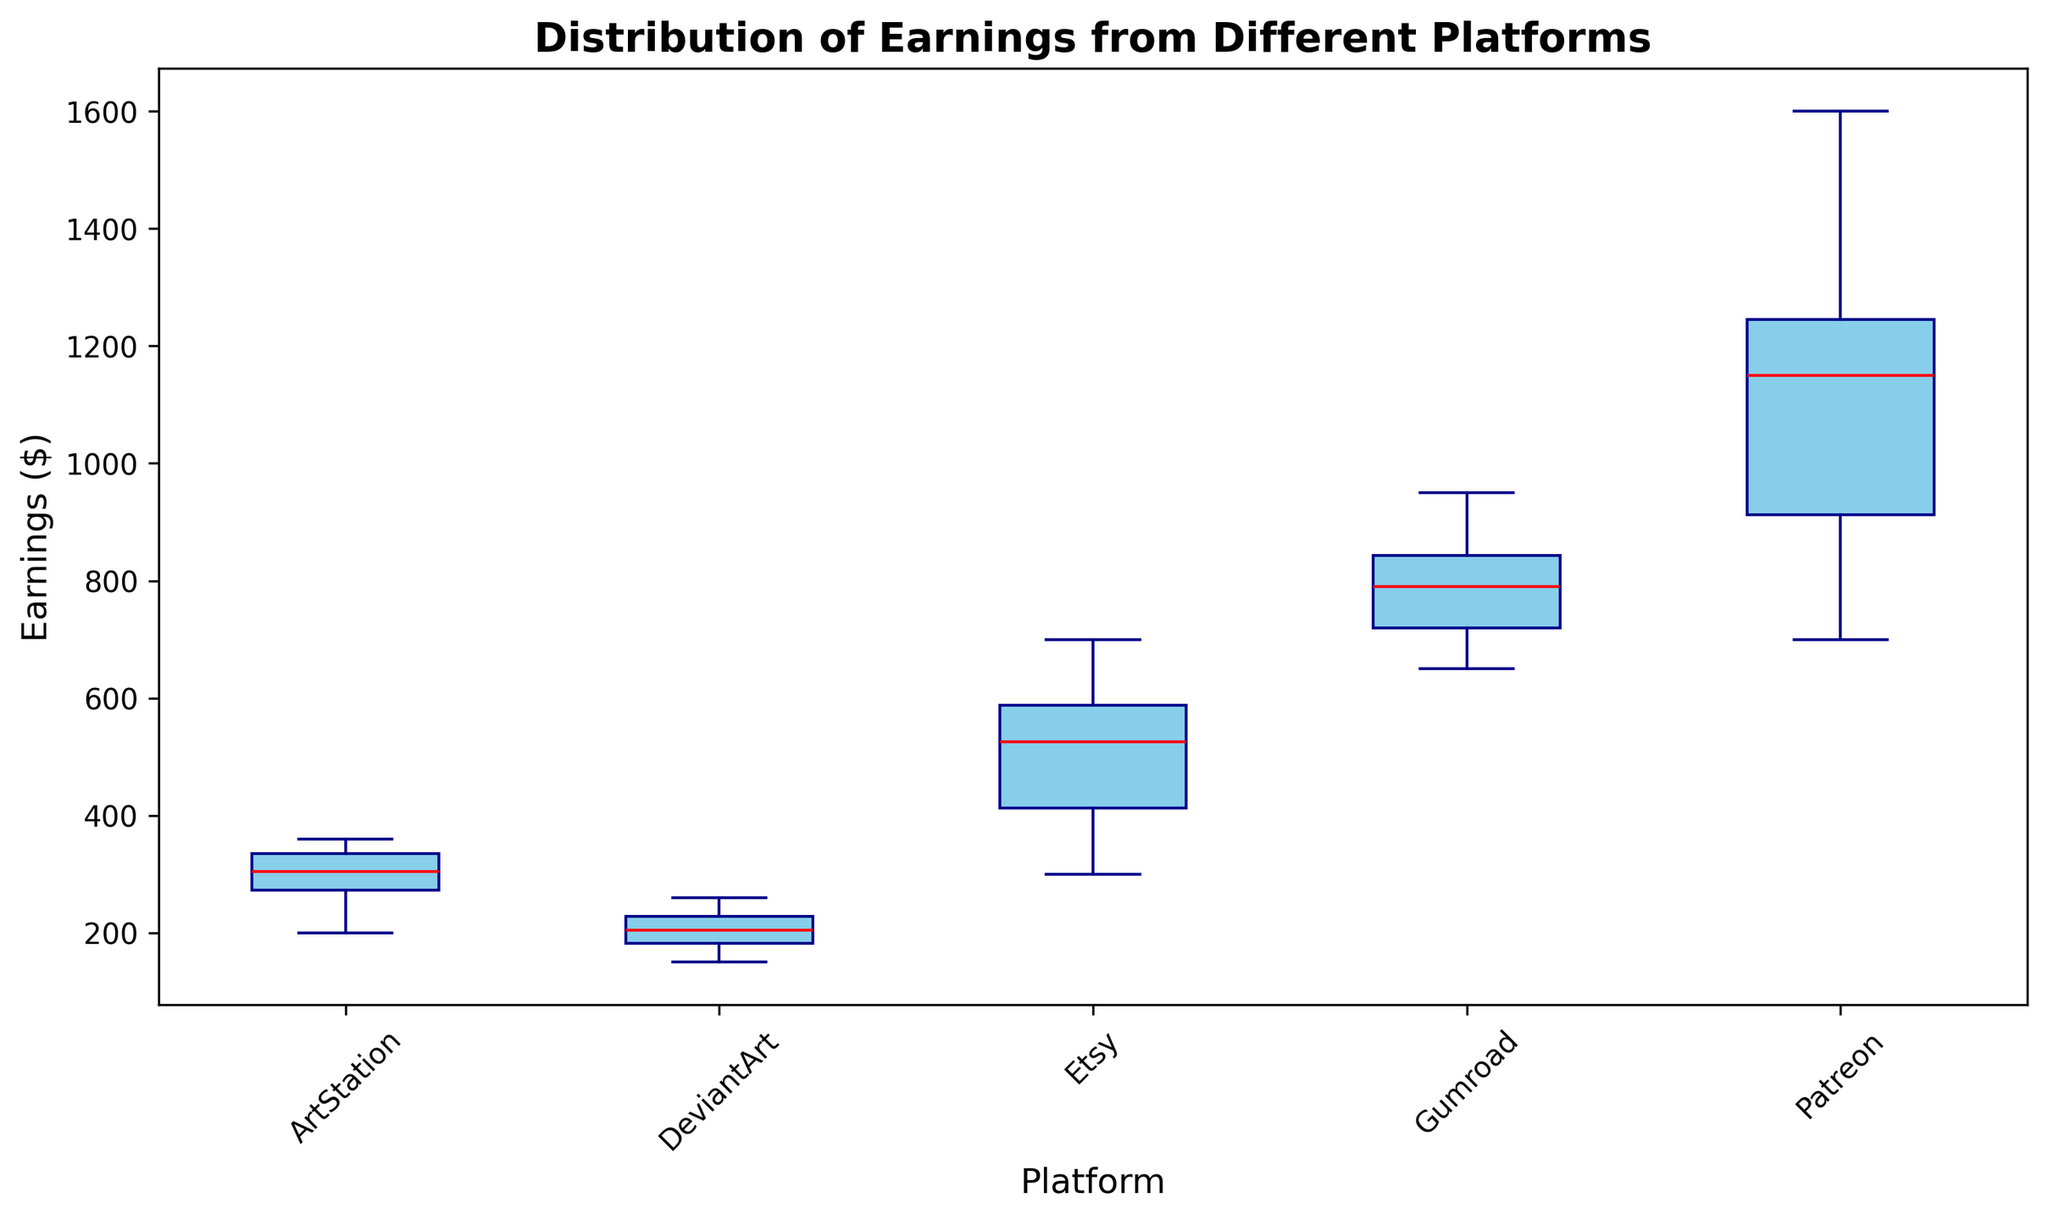Which platform has the highest median earnings? The median value is represented by the red line within each box. The platform with the highest median is identified by locating the red line that is at the highest vertical position among all platforms.
Answer: Patreon Which platform has the lowest earnings range? The range of earnings is indicated by the distance between the bottom and the top of each box, including the whiskers. The platform with the smallest vertical length between these elements has the lowest range.
Answer: DeviantArt Is the median earnings on Patreon greater than the median earnings on Etsy? Compare the position of the red line within the box for Patreon against the red line within the box for Etsy. The red line for Patreon is higher.
Answer: Yes Which platform has the widest interquartile range (IQR)? The IQR is represented by the height of the box. Identify the platform whose box has the greatest vertical extent.
Answer: Patreon How do the modal values compare across platforms? The mode isn't explicitly shown in the box plot. To find the mode, you’d need the individual earnings data, but the plot doesn't directly provide this information.
Answer: Not Answerable Which platform shows evidence of outliers? Outliers are usually shown as individual points above or below the 'whiskers' of the box plot. Identify platforms with such points.
Answer: Patreon Between DeviantArt and ArtStation, which has a higher third quartile? The third quartile is the top of the box. Compare the vertical position of the top edge of the box between DeviantArt and ArtStation.
Answer: ArtStation Which platform has the most consistent earnings among its users? Consistency in earnings can be inferred by a smaller interquartile range and shorter whiskers. Identify the platform with the smallest box and shorter whiskers.
Answer: DeviantArt 